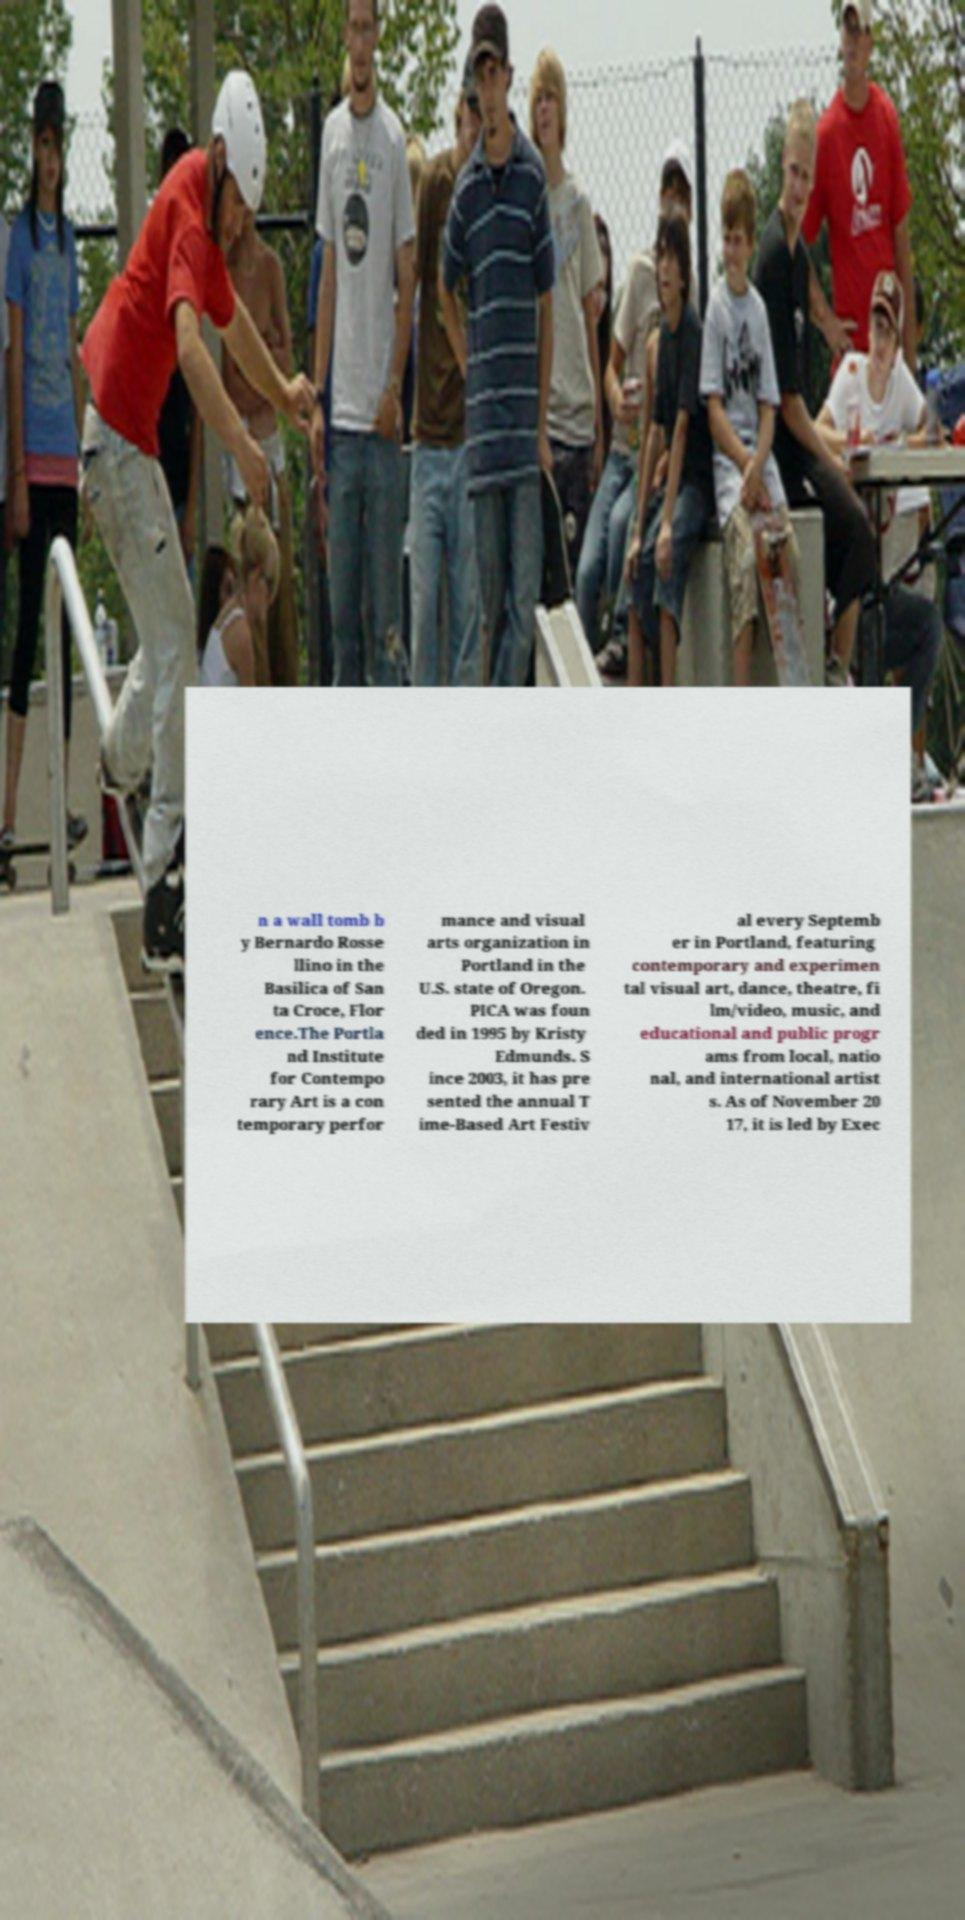Please read and relay the text visible in this image. What does it say? n a wall tomb b y Bernardo Rosse llino in the Basilica of San ta Croce, Flor ence.The Portla nd Institute for Contempo rary Art is a con temporary perfor mance and visual arts organization in Portland in the U.S. state of Oregon. PICA was foun ded in 1995 by Kristy Edmunds. S ince 2003, it has pre sented the annual T ime-Based Art Festiv al every Septemb er in Portland, featuring contemporary and experimen tal visual art, dance, theatre, fi lm/video, music, and educational and public progr ams from local, natio nal, and international artist s. As of November 20 17, it is led by Exec 